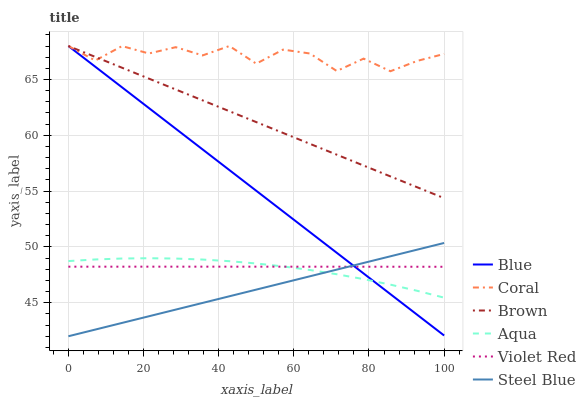Does Brown have the minimum area under the curve?
Answer yes or no. No. Does Brown have the maximum area under the curve?
Answer yes or no. No. Is Brown the smoothest?
Answer yes or no. No. Is Brown the roughest?
Answer yes or no. No. Does Brown have the lowest value?
Answer yes or no. No. Does Violet Red have the highest value?
Answer yes or no. No. Is Aqua less than Coral?
Answer yes or no. Yes. Is Coral greater than Violet Red?
Answer yes or no. Yes. Does Aqua intersect Coral?
Answer yes or no. No. 